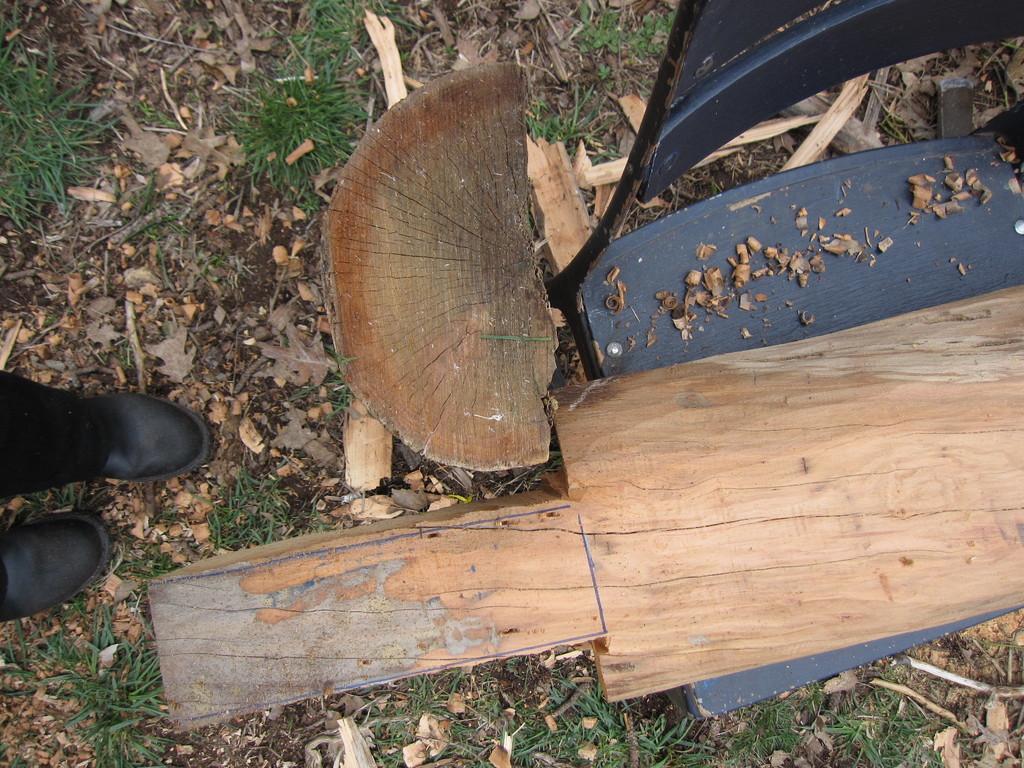How would you summarize this image in a sentence or two? In this picture there is a chair on the right. On the chair there is a log, beside it there is another log. Towards the left there is a person, only boots can be seen. 